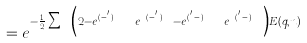Convert formula to latex. <formula><loc_0><loc_0><loc_500><loc_500>= e ^ { - \frac { 1 } { 2 } \sum _ { { q } n } \left ( 2 - e ^ { i { q } . ( { x } - { x } ^ { ^ { \prime } } ) } e ^ { z _ { n } ( t - t ^ { ^ { \prime } } ) } - e ^ { i { q } . ( { x } ^ { ^ { \prime } } - { x } ) } e ^ { z _ { n } ( t ^ { ^ { \prime } } - t ) } \right ) E ( { q } , n ) }</formula> 